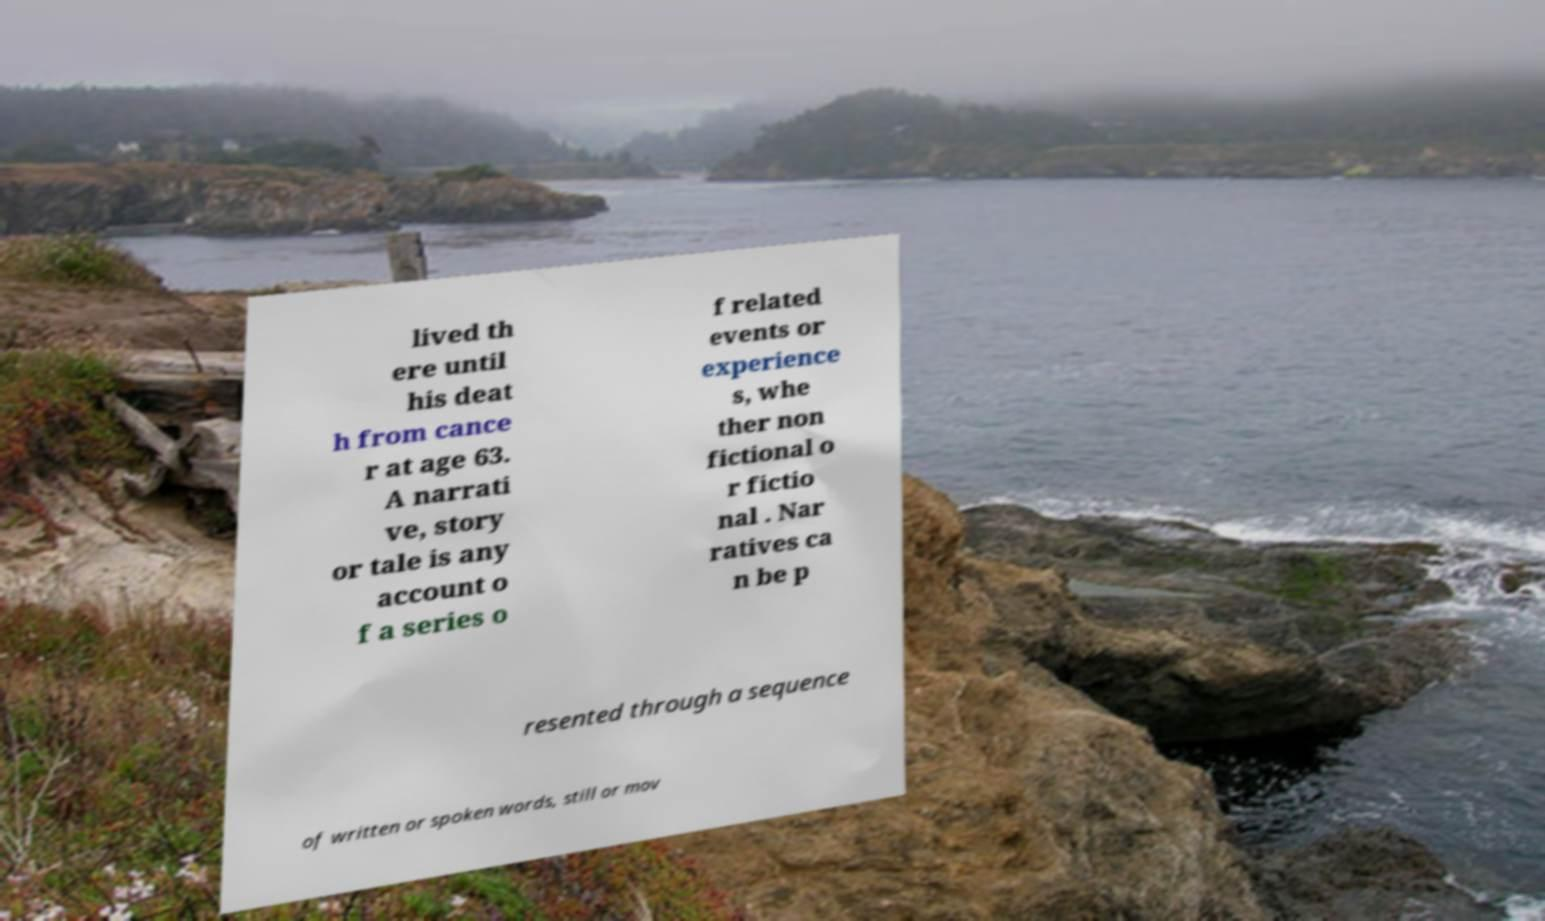Please read and relay the text visible in this image. What does it say? lived th ere until his deat h from cance r at age 63. A narrati ve, story or tale is any account o f a series o f related events or experience s, whe ther non fictional o r fictio nal . Nar ratives ca n be p resented through a sequence of written or spoken words, still or mov 